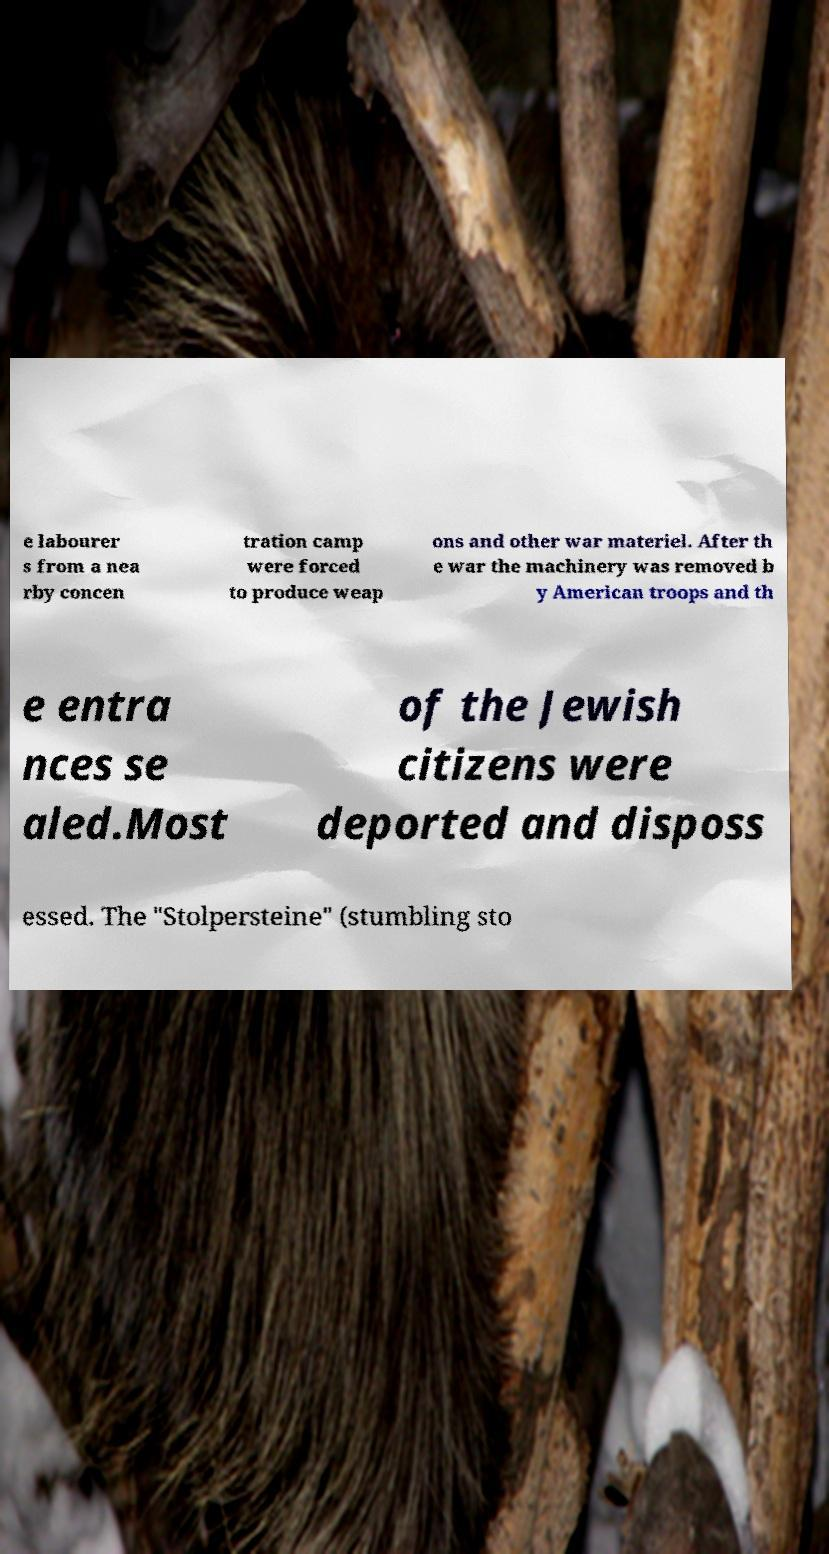I need the written content from this picture converted into text. Can you do that? e labourer s from a nea rby concen tration camp were forced to produce weap ons and other war materiel. After th e war the machinery was removed b y American troops and th e entra nces se aled.Most of the Jewish citizens were deported and disposs essed. The "Stolpersteine" (stumbling sto 